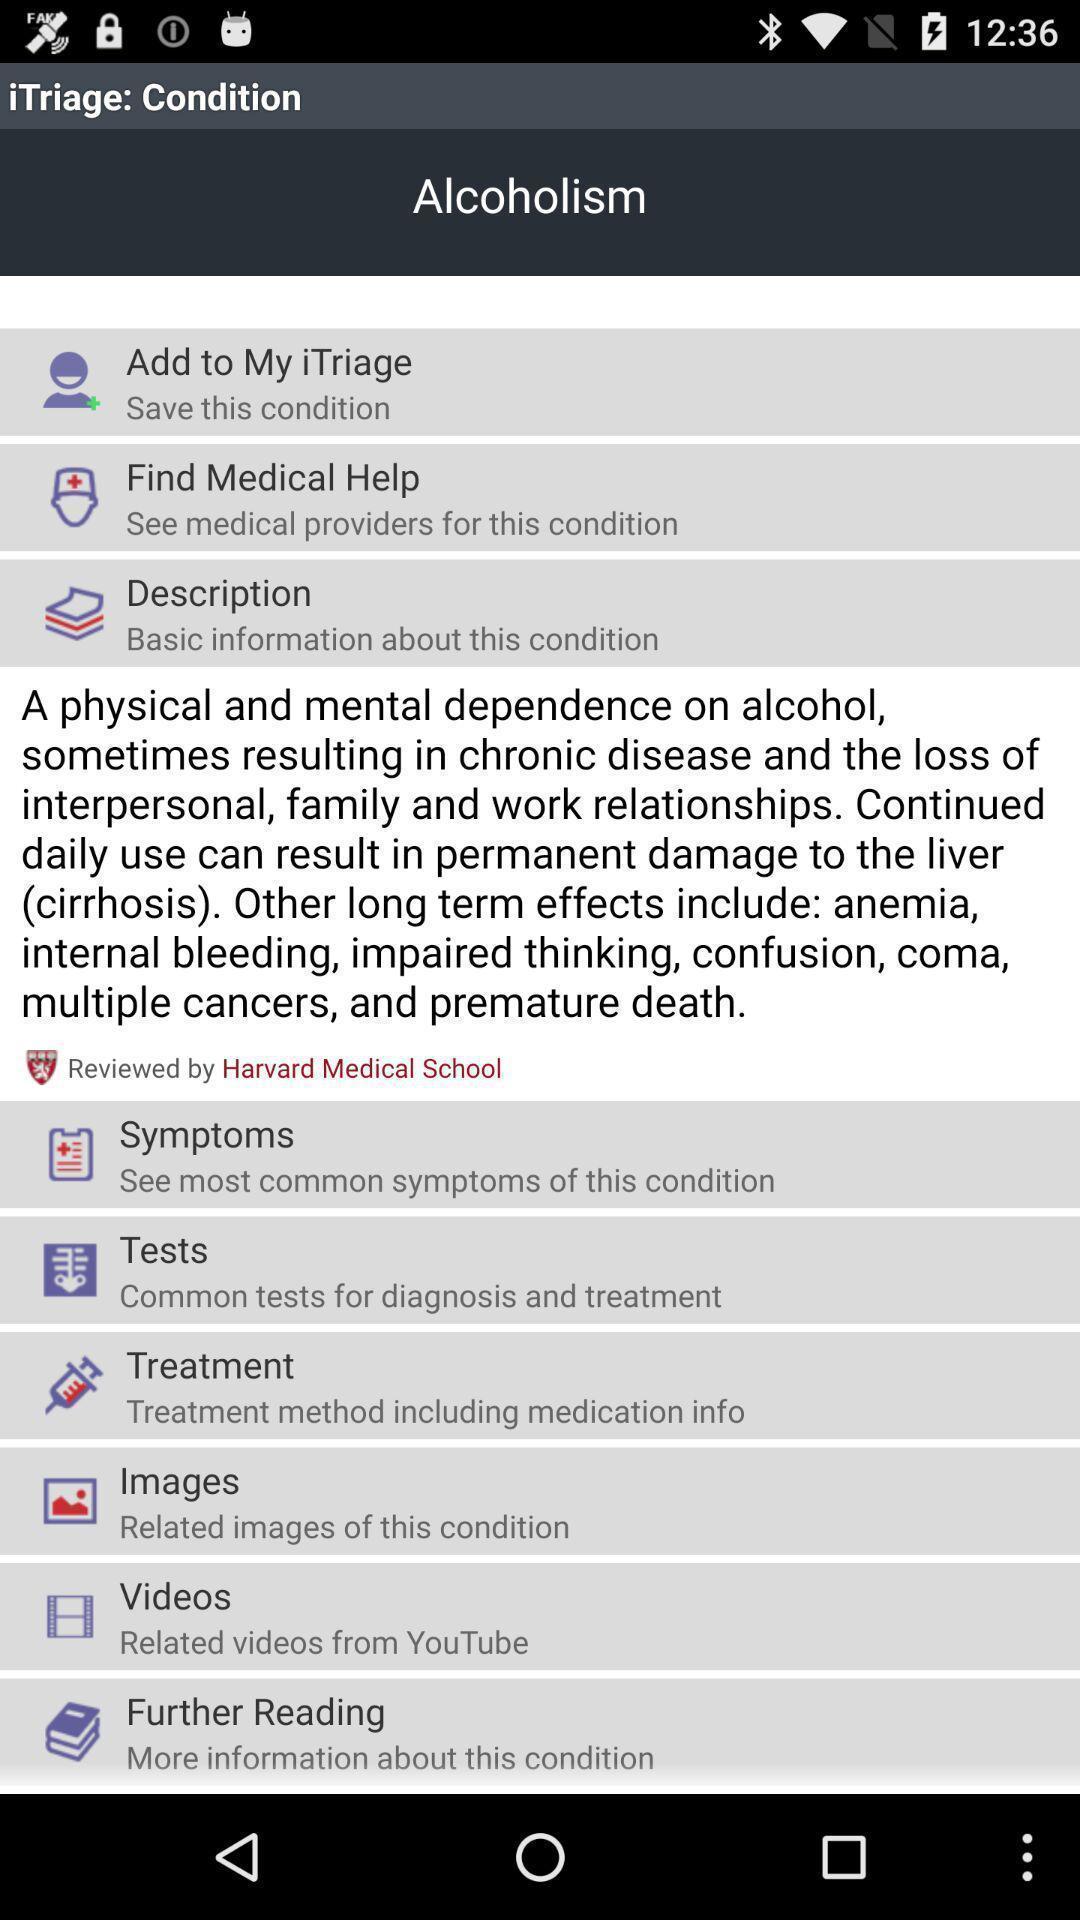Provide a detailed account of this screenshot. Screen showing various categories in a health app. 